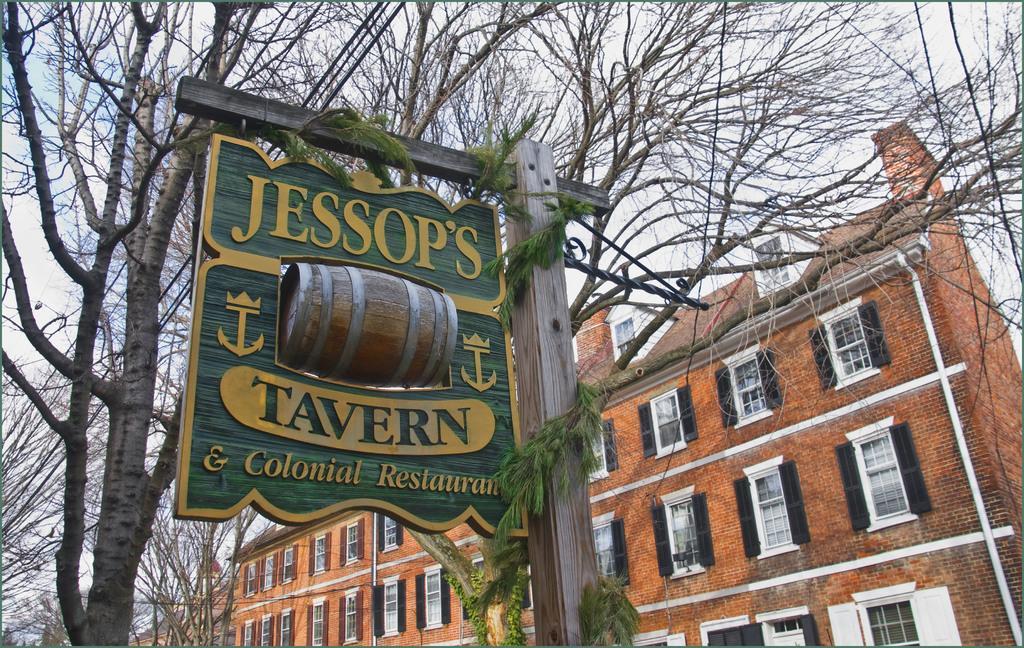Could you give a brief overview of what you see in this image? In this image in the front there is a pole and on the pole there is a board with some text written on it. In the center there are trees. In the background there are buildings. 